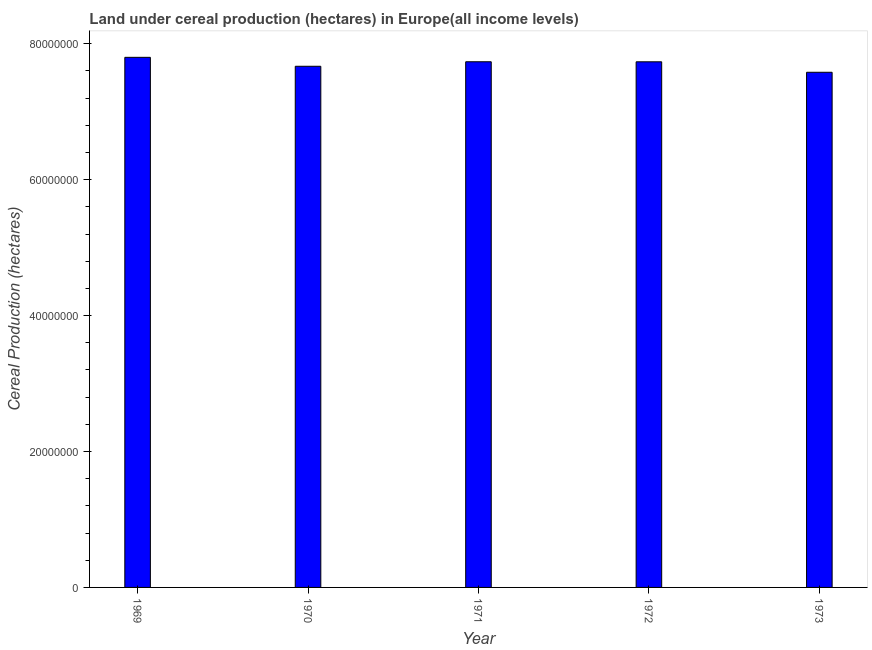Does the graph contain grids?
Offer a very short reply. No. What is the title of the graph?
Give a very brief answer. Land under cereal production (hectares) in Europe(all income levels). What is the label or title of the X-axis?
Your answer should be compact. Year. What is the label or title of the Y-axis?
Your response must be concise. Cereal Production (hectares). What is the land under cereal production in 1969?
Offer a very short reply. 7.80e+07. Across all years, what is the maximum land under cereal production?
Provide a succinct answer. 7.80e+07. Across all years, what is the minimum land under cereal production?
Your response must be concise. 7.58e+07. In which year was the land under cereal production maximum?
Make the answer very short. 1969. What is the sum of the land under cereal production?
Ensure brevity in your answer.  3.85e+08. What is the difference between the land under cereal production in 1970 and 1972?
Your answer should be very brief. -6.57e+05. What is the average land under cereal production per year?
Your answer should be compact. 7.70e+07. What is the median land under cereal production?
Provide a succinct answer. 7.73e+07. Do a majority of the years between 1973 and 1969 (inclusive) have land under cereal production greater than 32000000 hectares?
Your answer should be compact. Yes. What is the ratio of the land under cereal production in 1969 to that in 1971?
Ensure brevity in your answer.  1.01. Is the land under cereal production in 1969 less than that in 1973?
Offer a terse response. No. Is the difference between the land under cereal production in 1971 and 1973 greater than the difference between any two years?
Ensure brevity in your answer.  No. What is the difference between the highest and the second highest land under cereal production?
Provide a succinct answer. 6.52e+05. What is the difference between the highest and the lowest land under cereal production?
Make the answer very short. 2.20e+06. Are all the bars in the graph horizontal?
Give a very brief answer. No. How many years are there in the graph?
Your answer should be compact. 5. Are the values on the major ticks of Y-axis written in scientific E-notation?
Offer a very short reply. No. What is the Cereal Production (hectares) in 1969?
Make the answer very short. 7.80e+07. What is the Cereal Production (hectares) of 1970?
Offer a very short reply. 7.67e+07. What is the Cereal Production (hectares) in 1971?
Offer a very short reply. 7.74e+07. What is the Cereal Production (hectares) of 1972?
Ensure brevity in your answer.  7.73e+07. What is the Cereal Production (hectares) of 1973?
Your answer should be compact. 7.58e+07. What is the difference between the Cereal Production (hectares) in 1969 and 1970?
Provide a short and direct response. 1.32e+06. What is the difference between the Cereal Production (hectares) in 1969 and 1971?
Your answer should be very brief. 6.52e+05. What is the difference between the Cereal Production (hectares) in 1969 and 1972?
Your answer should be very brief. 6.59e+05. What is the difference between the Cereal Production (hectares) in 1969 and 1973?
Provide a short and direct response. 2.20e+06. What is the difference between the Cereal Production (hectares) in 1970 and 1971?
Make the answer very short. -6.63e+05. What is the difference between the Cereal Production (hectares) in 1970 and 1972?
Ensure brevity in your answer.  -6.57e+05. What is the difference between the Cereal Production (hectares) in 1970 and 1973?
Your answer should be compact. 8.84e+05. What is the difference between the Cereal Production (hectares) in 1971 and 1972?
Your answer should be compact. 6505. What is the difference between the Cereal Production (hectares) in 1971 and 1973?
Keep it short and to the point. 1.55e+06. What is the difference between the Cereal Production (hectares) in 1972 and 1973?
Make the answer very short. 1.54e+06. What is the ratio of the Cereal Production (hectares) in 1969 to that in 1973?
Your answer should be very brief. 1.03. What is the ratio of the Cereal Production (hectares) in 1970 to that in 1971?
Make the answer very short. 0.99. 